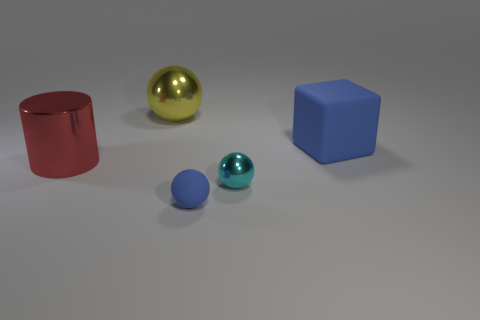What number of tiny balls are behind the metallic thing on the left side of the yellow thing?
Give a very brief answer. 0. Is the cube made of the same material as the yellow ball?
Give a very brief answer. No. There is a thing that is the same color as the rubber block; what size is it?
Provide a succinct answer. Small. Are there any tiny yellow cubes that have the same material as the cyan thing?
Your response must be concise. No. There is a metal ball left of the small thing to the left of the small thing that is behind the tiny blue matte object; what is its color?
Ensure brevity in your answer.  Yellow. How many cyan objects are either spheres or big cubes?
Provide a short and direct response. 1. How many other big shiny things have the same shape as the large red shiny object?
Give a very brief answer. 0. What is the shape of the metal object that is the same size as the matte ball?
Make the answer very short. Sphere. Are there any blue cubes behind the tiny blue matte thing?
Provide a succinct answer. Yes. Is there a red object to the left of the tiny thing that is behind the small matte object?
Keep it short and to the point. Yes. 